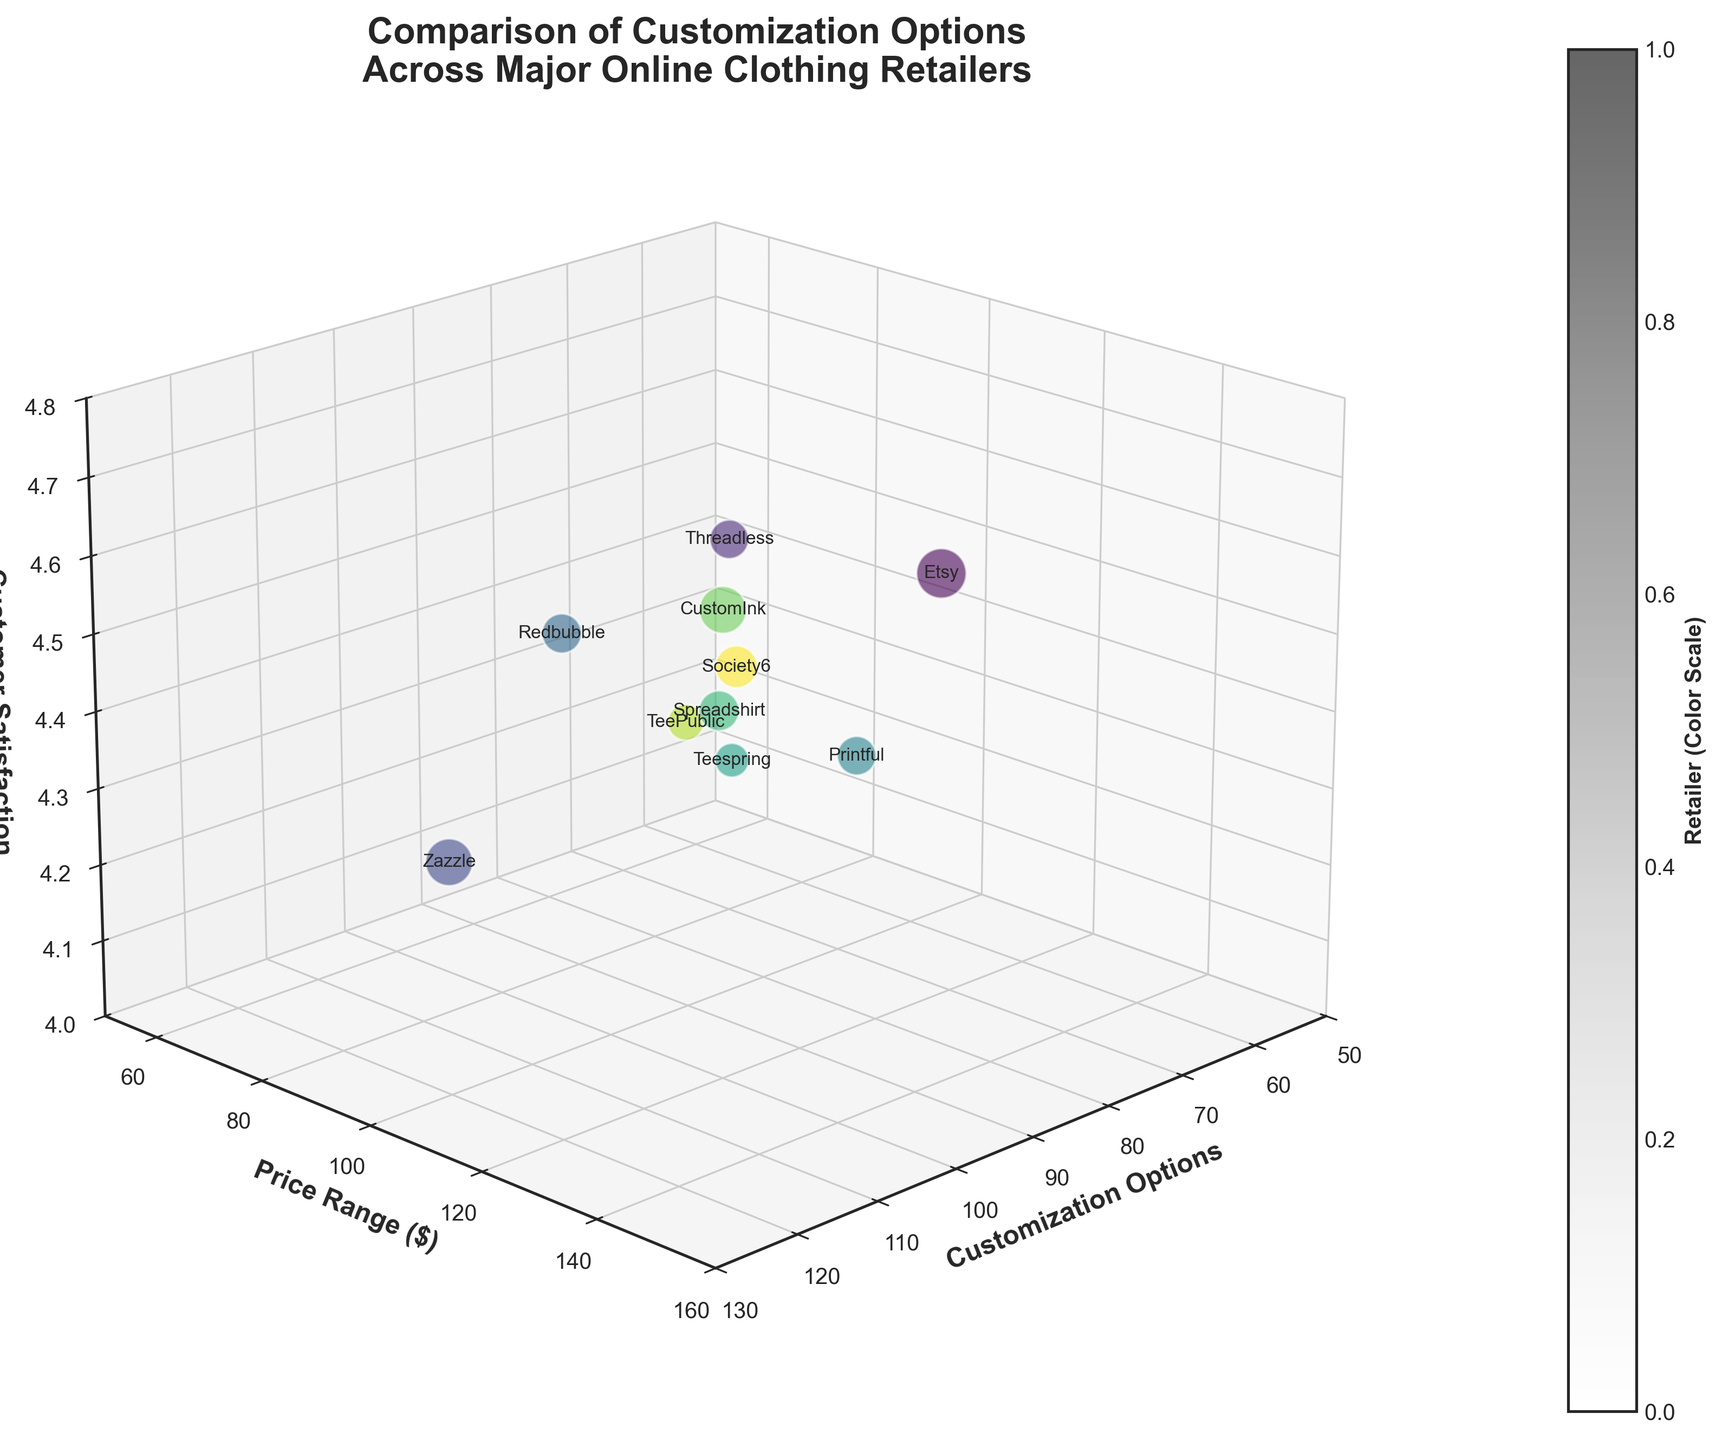Which retailer offers the highest number of customization options? By looking at the data points on the x-axis labeled 'Customization Options', the point farthest to the right represents the retailer with the most options.
Answer: Zazzle What is the price range for Etsy? By looking at Etsy's data point on the y-axis labeled 'Price Range ($)', you find the value directly.
Answer: $150 Which retailer has the highest customer satisfaction? By observing the z-axis labeled 'Customer Satisfaction' and identifying the highest point, you find the retailer.
Answer: Etsy Do Threadless and Spreadshirt fall within the same Price Range? By comparing the y-axis values for Threadless and Spreadshirt, you notice that although their price ranges are close, they are not the same.
Answer: No What's the total number of customization options for Printful and TeePublic combined? Printful has 60 customization options, TeePublic has 65. Adding them up gives 60 + 65 = 125.
Answer: 125 Which retailer has a higher Customer Satisfaction, Redbubble or Society6? By comparing the z-axis values for Redbubble (4.4) and Society6 (4.4), you find they are equal.
Answer: They are equal Which retailer sits in the mid-range for both Customization Options and Price Range? By observing the middle range values for both x (Customization Options) and y (Price Range) axes, you find the retailer near the middle.
Answer: Redbubble Is there a retailer that has both a high number of customization options and high customer satisfaction? By looking at the data points with high x (Customization Options) and z (Customer Satisfaction) values simultaneously, you identify the retailer.
Answer: Etsy What's the average Customer Satisfaction across all listed retailers? Sum all customer satisfaction values (4.7 + 4.5 + 4.3 + 4.4 + 4.2 + 4.1 + 4.3 + 4.6 + 4.2 + 4.4 = 43.7), then divide by the number of retailers (10). The result is 43.7 / 10 = 4.37.
Answer: 4.37 If you remove the retailer with the lowest Price Range, what's the new average Price Range across the remaining retailers? Removing Teespring with Price Range 60; sum remaining values: 150 + 80 + 100 + 70 + 90 + 85 + 120 + 65 + 95 = 855; divide by 9. The result is 855 / 9 ≈ 95.
Answer: 95 